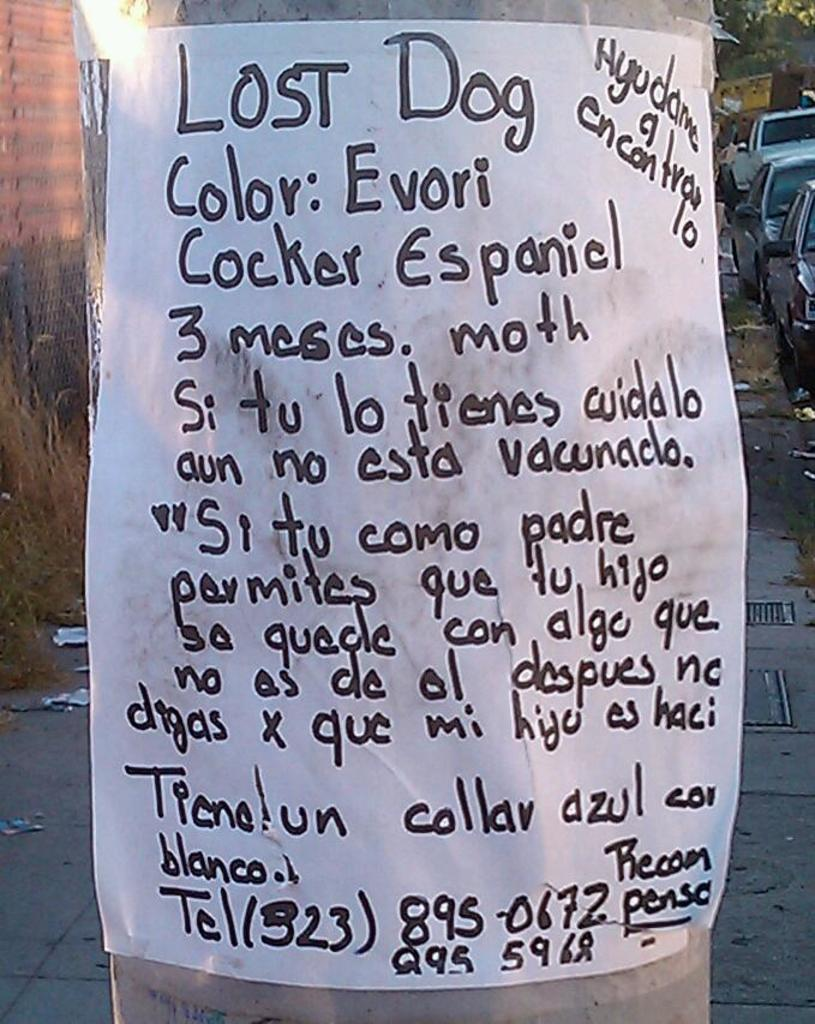What is present on the poster in the image? Unfortunately, the provided facts do not specify what is on the poster. However, we can confirm that there is a poster in the image. What types of vehicles can be seen on the ground in the image? The provided facts do not specify the types of vehicles on the ground. However, we can confirm that there are vehicles on the ground in the image. How many beetles can be seen joining the poster in the image? There are no beetles present in the image, and therefore no such activity can be observed. 